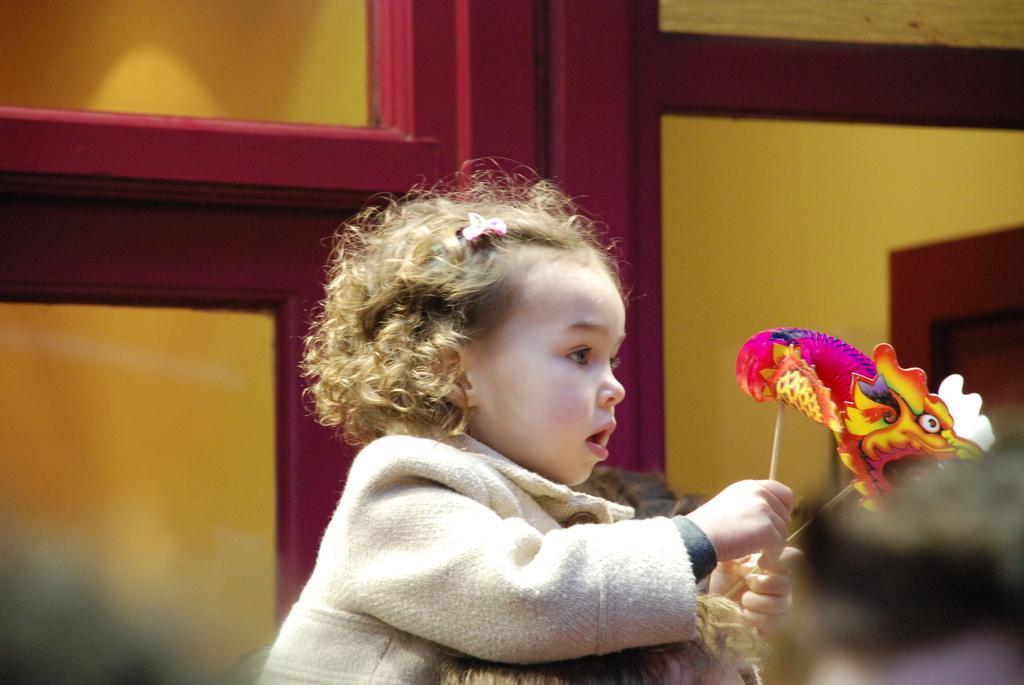In one or two sentences, can you explain what this image depicts? In this image a girl is wearing a jacket and she is holding stick having few masks on it. Bottom of image there is a person. Behind it there is a glass door. 